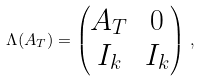Convert formula to latex. <formula><loc_0><loc_0><loc_500><loc_500>\Lambda ( A _ { T } ) = \begin{pmatrix} A _ { T } & 0 \\ I _ { k } & I _ { k } \end{pmatrix} \, ,</formula> 